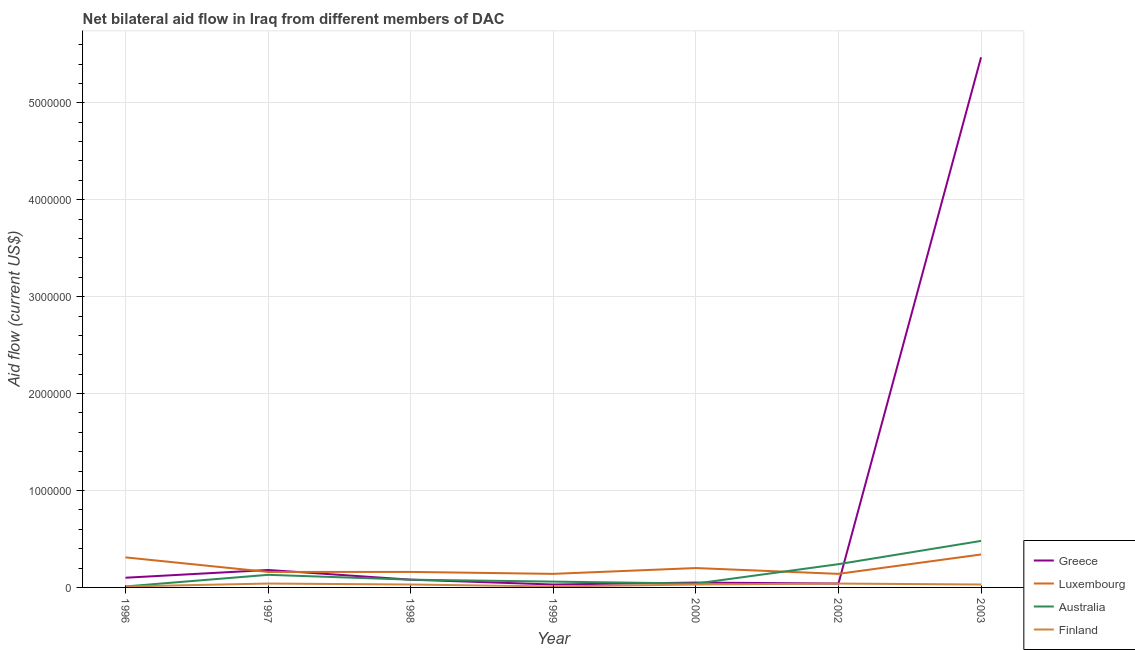What is the amount of aid given by australia in 2000?
Provide a short and direct response. 4.00e+04. Across all years, what is the maximum amount of aid given by luxembourg?
Give a very brief answer. 3.40e+05. Across all years, what is the minimum amount of aid given by greece?
Provide a succinct answer. 3.00e+04. In which year was the amount of aid given by australia minimum?
Your answer should be very brief. 1996. What is the total amount of aid given by luxembourg in the graph?
Make the answer very short. 1.45e+06. What is the difference between the amount of aid given by australia in 1998 and that in 1999?
Offer a very short reply. 2.00e+04. What is the difference between the amount of aid given by finland in 1997 and the amount of aid given by australia in 2003?
Make the answer very short. -4.40e+05. What is the average amount of aid given by australia per year?
Keep it short and to the point. 1.49e+05. In the year 2003, what is the difference between the amount of aid given by finland and amount of aid given by australia?
Ensure brevity in your answer.  -4.50e+05. In how many years, is the amount of aid given by australia greater than 4600000 US$?
Provide a succinct answer. 0. What is the ratio of the amount of aid given by luxembourg in 2000 to that in 2002?
Offer a terse response. 1.43. Is the difference between the amount of aid given by luxembourg in 1996 and 2003 greater than the difference between the amount of aid given by greece in 1996 and 2003?
Ensure brevity in your answer.  Yes. What is the difference between the highest and the second highest amount of aid given by greece?
Your answer should be compact. 5.29e+06. What is the difference between the highest and the lowest amount of aid given by australia?
Provide a short and direct response. 4.70e+05. In how many years, is the amount of aid given by luxembourg greater than the average amount of aid given by luxembourg taken over all years?
Provide a short and direct response. 2. Is the sum of the amount of aid given by finland in 1999 and 2002 greater than the maximum amount of aid given by luxembourg across all years?
Offer a terse response. No. Is it the case that in every year, the sum of the amount of aid given by greece and amount of aid given by luxembourg is greater than the amount of aid given by australia?
Provide a succinct answer. No. Does the amount of aid given by australia monotonically increase over the years?
Your answer should be very brief. No. Is the amount of aid given by greece strictly greater than the amount of aid given by luxembourg over the years?
Give a very brief answer. No. Is the amount of aid given by australia strictly less than the amount of aid given by luxembourg over the years?
Provide a succinct answer. No. How many lines are there?
Ensure brevity in your answer.  4. What is the difference between two consecutive major ticks on the Y-axis?
Keep it short and to the point. 1.00e+06. Does the graph contain any zero values?
Your answer should be very brief. No. Does the graph contain grids?
Make the answer very short. Yes. How many legend labels are there?
Ensure brevity in your answer.  4. What is the title of the graph?
Provide a short and direct response. Net bilateral aid flow in Iraq from different members of DAC. What is the label or title of the Y-axis?
Ensure brevity in your answer.  Aid flow (current US$). What is the Aid flow (current US$) of Luxembourg in 1996?
Provide a succinct answer. 3.10e+05. What is the Aid flow (current US$) in Australia in 1996?
Keep it short and to the point. 10000. What is the Aid flow (current US$) in Finland in 1996?
Make the answer very short. 10000. What is the Aid flow (current US$) of Australia in 1997?
Your response must be concise. 1.30e+05. What is the Aid flow (current US$) of Greece in 1998?
Your response must be concise. 8.00e+04. What is the Aid flow (current US$) of Greece in 1999?
Ensure brevity in your answer.  3.00e+04. What is the Aid flow (current US$) of Luxembourg in 1999?
Your answer should be very brief. 1.40e+05. What is the Aid flow (current US$) in Australia in 1999?
Your answer should be very brief. 6.00e+04. What is the Aid flow (current US$) in Greece in 2000?
Your response must be concise. 5.00e+04. What is the Aid flow (current US$) of Luxembourg in 2000?
Ensure brevity in your answer.  2.00e+05. What is the Aid flow (current US$) of Australia in 2000?
Give a very brief answer. 4.00e+04. What is the Aid flow (current US$) in Australia in 2002?
Your answer should be very brief. 2.40e+05. What is the Aid flow (current US$) of Finland in 2002?
Keep it short and to the point. 4.00e+04. What is the Aid flow (current US$) in Greece in 2003?
Make the answer very short. 5.47e+06. What is the Aid flow (current US$) in Australia in 2003?
Offer a terse response. 4.80e+05. What is the Aid flow (current US$) of Finland in 2003?
Give a very brief answer. 3.00e+04. Across all years, what is the maximum Aid flow (current US$) in Greece?
Offer a terse response. 5.47e+06. Across all years, what is the maximum Aid flow (current US$) in Luxembourg?
Offer a very short reply. 3.40e+05. Across all years, what is the maximum Aid flow (current US$) of Australia?
Your answer should be very brief. 4.80e+05. What is the total Aid flow (current US$) in Greece in the graph?
Your response must be concise. 5.95e+06. What is the total Aid flow (current US$) in Luxembourg in the graph?
Provide a short and direct response. 1.45e+06. What is the total Aid flow (current US$) in Australia in the graph?
Make the answer very short. 1.04e+06. What is the total Aid flow (current US$) of Finland in the graph?
Offer a very short reply. 1.90e+05. What is the difference between the Aid flow (current US$) in Greece in 1996 and that in 1997?
Give a very brief answer. -8.00e+04. What is the difference between the Aid flow (current US$) in Luxembourg in 1996 and that in 1997?
Your response must be concise. 1.50e+05. What is the difference between the Aid flow (current US$) of Australia in 1996 and that in 1997?
Provide a succinct answer. -1.20e+05. What is the difference between the Aid flow (current US$) in Finland in 1996 and that in 1997?
Your answer should be compact. -3.00e+04. What is the difference between the Aid flow (current US$) of Greece in 1996 and that in 1998?
Provide a short and direct response. 2.00e+04. What is the difference between the Aid flow (current US$) in Finland in 1996 and that in 1998?
Your answer should be compact. -2.00e+04. What is the difference between the Aid flow (current US$) in Finland in 1996 and that in 1999?
Make the answer very short. 0. What is the difference between the Aid flow (current US$) of Greece in 1996 and that in 2000?
Your answer should be very brief. 5.00e+04. What is the difference between the Aid flow (current US$) of Australia in 1996 and that in 2000?
Make the answer very short. -3.00e+04. What is the difference between the Aid flow (current US$) of Luxembourg in 1996 and that in 2002?
Your response must be concise. 1.70e+05. What is the difference between the Aid flow (current US$) of Greece in 1996 and that in 2003?
Offer a terse response. -5.37e+06. What is the difference between the Aid flow (current US$) of Luxembourg in 1996 and that in 2003?
Provide a succinct answer. -3.00e+04. What is the difference between the Aid flow (current US$) in Australia in 1996 and that in 2003?
Provide a short and direct response. -4.70e+05. What is the difference between the Aid flow (current US$) of Finland in 1996 and that in 2003?
Provide a short and direct response. -2.00e+04. What is the difference between the Aid flow (current US$) of Australia in 1997 and that in 1998?
Offer a terse response. 5.00e+04. What is the difference between the Aid flow (current US$) of Finland in 1997 and that in 1998?
Offer a very short reply. 10000. What is the difference between the Aid flow (current US$) of Luxembourg in 1997 and that in 1999?
Your answer should be compact. 2.00e+04. What is the difference between the Aid flow (current US$) in Australia in 1997 and that in 1999?
Provide a succinct answer. 7.00e+04. What is the difference between the Aid flow (current US$) in Luxembourg in 1997 and that in 2000?
Provide a succinct answer. -4.00e+04. What is the difference between the Aid flow (current US$) in Australia in 1997 and that in 2000?
Make the answer very short. 9.00e+04. What is the difference between the Aid flow (current US$) of Finland in 1997 and that in 2000?
Your answer should be compact. 10000. What is the difference between the Aid flow (current US$) of Greece in 1997 and that in 2002?
Offer a very short reply. 1.40e+05. What is the difference between the Aid flow (current US$) in Luxembourg in 1997 and that in 2002?
Make the answer very short. 2.00e+04. What is the difference between the Aid flow (current US$) of Finland in 1997 and that in 2002?
Your answer should be compact. 0. What is the difference between the Aid flow (current US$) of Greece in 1997 and that in 2003?
Keep it short and to the point. -5.29e+06. What is the difference between the Aid flow (current US$) in Luxembourg in 1997 and that in 2003?
Ensure brevity in your answer.  -1.80e+05. What is the difference between the Aid flow (current US$) of Australia in 1997 and that in 2003?
Give a very brief answer. -3.50e+05. What is the difference between the Aid flow (current US$) of Finland in 1997 and that in 2003?
Your response must be concise. 10000. What is the difference between the Aid flow (current US$) in Luxembourg in 1998 and that in 1999?
Provide a short and direct response. 2.00e+04. What is the difference between the Aid flow (current US$) of Australia in 1998 and that in 1999?
Your answer should be very brief. 2.00e+04. What is the difference between the Aid flow (current US$) of Finland in 1998 and that in 1999?
Offer a terse response. 2.00e+04. What is the difference between the Aid flow (current US$) in Luxembourg in 1998 and that in 2000?
Offer a terse response. -4.00e+04. What is the difference between the Aid flow (current US$) in Finland in 1998 and that in 2000?
Make the answer very short. 0. What is the difference between the Aid flow (current US$) of Greece in 1998 and that in 2002?
Offer a very short reply. 4.00e+04. What is the difference between the Aid flow (current US$) in Luxembourg in 1998 and that in 2002?
Your answer should be very brief. 2.00e+04. What is the difference between the Aid flow (current US$) in Australia in 1998 and that in 2002?
Your answer should be compact. -1.60e+05. What is the difference between the Aid flow (current US$) of Finland in 1998 and that in 2002?
Your answer should be very brief. -10000. What is the difference between the Aid flow (current US$) of Greece in 1998 and that in 2003?
Give a very brief answer. -5.39e+06. What is the difference between the Aid flow (current US$) in Luxembourg in 1998 and that in 2003?
Give a very brief answer. -1.80e+05. What is the difference between the Aid flow (current US$) in Australia in 1998 and that in 2003?
Ensure brevity in your answer.  -4.00e+05. What is the difference between the Aid flow (current US$) in Finland in 1998 and that in 2003?
Provide a succinct answer. 0. What is the difference between the Aid flow (current US$) of Greece in 1999 and that in 2000?
Ensure brevity in your answer.  -2.00e+04. What is the difference between the Aid flow (current US$) of Luxembourg in 1999 and that in 2000?
Keep it short and to the point. -6.00e+04. What is the difference between the Aid flow (current US$) in Australia in 1999 and that in 2000?
Your response must be concise. 2.00e+04. What is the difference between the Aid flow (current US$) in Finland in 1999 and that in 2000?
Your answer should be very brief. -2.00e+04. What is the difference between the Aid flow (current US$) of Greece in 1999 and that in 2002?
Keep it short and to the point. -10000. What is the difference between the Aid flow (current US$) of Luxembourg in 1999 and that in 2002?
Your answer should be compact. 0. What is the difference between the Aid flow (current US$) of Greece in 1999 and that in 2003?
Offer a very short reply. -5.44e+06. What is the difference between the Aid flow (current US$) of Australia in 1999 and that in 2003?
Your answer should be compact. -4.20e+05. What is the difference between the Aid flow (current US$) of Finland in 1999 and that in 2003?
Provide a succinct answer. -2.00e+04. What is the difference between the Aid flow (current US$) of Luxembourg in 2000 and that in 2002?
Your response must be concise. 6.00e+04. What is the difference between the Aid flow (current US$) in Greece in 2000 and that in 2003?
Provide a short and direct response. -5.42e+06. What is the difference between the Aid flow (current US$) in Luxembourg in 2000 and that in 2003?
Offer a terse response. -1.40e+05. What is the difference between the Aid flow (current US$) in Australia in 2000 and that in 2003?
Your response must be concise. -4.40e+05. What is the difference between the Aid flow (current US$) in Greece in 2002 and that in 2003?
Your response must be concise. -5.43e+06. What is the difference between the Aid flow (current US$) in Australia in 2002 and that in 2003?
Your answer should be compact. -2.40e+05. What is the difference between the Aid flow (current US$) in Greece in 1996 and the Aid flow (current US$) in Luxembourg in 1997?
Offer a terse response. -6.00e+04. What is the difference between the Aid flow (current US$) in Greece in 1996 and the Aid flow (current US$) in Finland in 1997?
Ensure brevity in your answer.  6.00e+04. What is the difference between the Aid flow (current US$) of Luxembourg in 1996 and the Aid flow (current US$) of Australia in 1997?
Provide a succinct answer. 1.80e+05. What is the difference between the Aid flow (current US$) in Luxembourg in 1996 and the Aid flow (current US$) in Finland in 1997?
Offer a terse response. 2.70e+05. What is the difference between the Aid flow (current US$) in Greece in 1996 and the Aid flow (current US$) in Luxembourg in 1998?
Provide a succinct answer. -6.00e+04. What is the difference between the Aid flow (current US$) in Greece in 1996 and the Aid flow (current US$) in Australia in 1998?
Your response must be concise. 2.00e+04. What is the difference between the Aid flow (current US$) in Greece in 1996 and the Aid flow (current US$) in Finland in 1998?
Keep it short and to the point. 7.00e+04. What is the difference between the Aid flow (current US$) of Luxembourg in 1996 and the Aid flow (current US$) of Australia in 1998?
Your answer should be compact. 2.30e+05. What is the difference between the Aid flow (current US$) of Luxembourg in 1996 and the Aid flow (current US$) of Finland in 1998?
Your answer should be compact. 2.80e+05. What is the difference between the Aid flow (current US$) of Greece in 1996 and the Aid flow (current US$) of Luxembourg in 1999?
Your answer should be very brief. -4.00e+04. What is the difference between the Aid flow (current US$) of Greece in 1996 and the Aid flow (current US$) of Finland in 1999?
Offer a terse response. 9.00e+04. What is the difference between the Aid flow (current US$) of Luxembourg in 1996 and the Aid flow (current US$) of Australia in 1999?
Ensure brevity in your answer.  2.50e+05. What is the difference between the Aid flow (current US$) of Luxembourg in 1996 and the Aid flow (current US$) of Finland in 1999?
Provide a short and direct response. 3.00e+05. What is the difference between the Aid flow (current US$) in Australia in 1996 and the Aid flow (current US$) in Finland in 1999?
Provide a succinct answer. 0. What is the difference between the Aid flow (current US$) in Greece in 1996 and the Aid flow (current US$) in Luxembourg in 2000?
Your answer should be compact. -1.00e+05. What is the difference between the Aid flow (current US$) in Greece in 1996 and the Aid flow (current US$) in Australia in 2000?
Offer a terse response. 6.00e+04. What is the difference between the Aid flow (current US$) in Greece in 1996 and the Aid flow (current US$) in Finland in 2000?
Provide a short and direct response. 7.00e+04. What is the difference between the Aid flow (current US$) in Luxembourg in 1996 and the Aid flow (current US$) in Australia in 2000?
Keep it short and to the point. 2.70e+05. What is the difference between the Aid flow (current US$) in Australia in 1996 and the Aid flow (current US$) in Finland in 2000?
Keep it short and to the point. -2.00e+04. What is the difference between the Aid flow (current US$) in Greece in 1996 and the Aid flow (current US$) in Finland in 2002?
Your answer should be very brief. 6.00e+04. What is the difference between the Aid flow (current US$) in Australia in 1996 and the Aid flow (current US$) in Finland in 2002?
Your answer should be very brief. -3.00e+04. What is the difference between the Aid flow (current US$) in Greece in 1996 and the Aid flow (current US$) in Luxembourg in 2003?
Keep it short and to the point. -2.40e+05. What is the difference between the Aid flow (current US$) of Greece in 1996 and the Aid flow (current US$) of Australia in 2003?
Your answer should be compact. -3.80e+05. What is the difference between the Aid flow (current US$) of Greece in 1996 and the Aid flow (current US$) of Finland in 2003?
Give a very brief answer. 7.00e+04. What is the difference between the Aid flow (current US$) in Luxembourg in 1996 and the Aid flow (current US$) in Finland in 2003?
Make the answer very short. 2.80e+05. What is the difference between the Aid flow (current US$) in Greece in 1997 and the Aid flow (current US$) in Luxembourg in 1998?
Keep it short and to the point. 2.00e+04. What is the difference between the Aid flow (current US$) of Greece in 1997 and the Aid flow (current US$) of Australia in 1998?
Your response must be concise. 1.00e+05. What is the difference between the Aid flow (current US$) in Luxembourg in 1997 and the Aid flow (current US$) in Australia in 1998?
Provide a succinct answer. 8.00e+04. What is the difference between the Aid flow (current US$) of Luxembourg in 1997 and the Aid flow (current US$) of Finland in 1998?
Your answer should be very brief. 1.30e+05. What is the difference between the Aid flow (current US$) in Greece in 1997 and the Aid flow (current US$) in Luxembourg in 1999?
Keep it short and to the point. 4.00e+04. What is the difference between the Aid flow (current US$) in Greece in 1997 and the Aid flow (current US$) in Finland in 1999?
Keep it short and to the point. 1.70e+05. What is the difference between the Aid flow (current US$) in Luxembourg in 1997 and the Aid flow (current US$) in Australia in 1999?
Your answer should be very brief. 1.00e+05. What is the difference between the Aid flow (current US$) in Luxembourg in 1997 and the Aid flow (current US$) in Finland in 1999?
Make the answer very short. 1.50e+05. What is the difference between the Aid flow (current US$) in Australia in 1997 and the Aid flow (current US$) in Finland in 1999?
Ensure brevity in your answer.  1.20e+05. What is the difference between the Aid flow (current US$) of Greece in 1997 and the Aid flow (current US$) of Australia in 2000?
Give a very brief answer. 1.40e+05. What is the difference between the Aid flow (current US$) in Greece in 1997 and the Aid flow (current US$) in Finland in 2000?
Your response must be concise. 1.50e+05. What is the difference between the Aid flow (current US$) of Luxembourg in 1997 and the Aid flow (current US$) of Australia in 2000?
Provide a succinct answer. 1.20e+05. What is the difference between the Aid flow (current US$) in Luxembourg in 1997 and the Aid flow (current US$) in Australia in 2002?
Provide a short and direct response. -8.00e+04. What is the difference between the Aid flow (current US$) of Luxembourg in 1997 and the Aid flow (current US$) of Finland in 2002?
Provide a short and direct response. 1.20e+05. What is the difference between the Aid flow (current US$) of Australia in 1997 and the Aid flow (current US$) of Finland in 2002?
Provide a succinct answer. 9.00e+04. What is the difference between the Aid flow (current US$) of Greece in 1997 and the Aid flow (current US$) of Australia in 2003?
Offer a terse response. -3.00e+05. What is the difference between the Aid flow (current US$) of Luxembourg in 1997 and the Aid flow (current US$) of Australia in 2003?
Offer a very short reply. -3.20e+05. What is the difference between the Aid flow (current US$) of Greece in 1998 and the Aid flow (current US$) of Australia in 1999?
Give a very brief answer. 2.00e+04. What is the difference between the Aid flow (current US$) in Australia in 1998 and the Aid flow (current US$) in Finland in 1999?
Keep it short and to the point. 7.00e+04. What is the difference between the Aid flow (current US$) of Greece in 1998 and the Aid flow (current US$) of Luxembourg in 2000?
Your answer should be very brief. -1.20e+05. What is the difference between the Aid flow (current US$) of Greece in 1998 and the Aid flow (current US$) of Finland in 2000?
Ensure brevity in your answer.  5.00e+04. What is the difference between the Aid flow (current US$) of Luxembourg in 1998 and the Aid flow (current US$) of Australia in 2000?
Make the answer very short. 1.20e+05. What is the difference between the Aid flow (current US$) of Greece in 1998 and the Aid flow (current US$) of Luxembourg in 2002?
Give a very brief answer. -6.00e+04. What is the difference between the Aid flow (current US$) of Luxembourg in 1998 and the Aid flow (current US$) of Australia in 2002?
Make the answer very short. -8.00e+04. What is the difference between the Aid flow (current US$) of Greece in 1998 and the Aid flow (current US$) of Luxembourg in 2003?
Ensure brevity in your answer.  -2.60e+05. What is the difference between the Aid flow (current US$) of Greece in 1998 and the Aid flow (current US$) of Australia in 2003?
Your response must be concise. -4.00e+05. What is the difference between the Aid flow (current US$) of Luxembourg in 1998 and the Aid flow (current US$) of Australia in 2003?
Offer a very short reply. -3.20e+05. What is the difference between the Aid flow (current US$) of Luxembourg in 1998 and the Aid flow (current US$) of Finland in 2003?
Offer a terse response. 1.30e+05. What is the difference between the Aid flow (current US$) of Australia in 1998 and the Aid flow (current US$) of Finland in 2003?
Your answer should be compact. 5.00e+04. What is the difference between the Aid flow (current US$) in Greece in 1999 and the Aid flow (current US$) in Luxembourg in 2000?
Your answer should be compact. -1.70e+05. What is the difference between the Aid flow (current US$) in Greece in 1999 and the Aid flow (current US$) in Australia in 2000?
Provide a short and direct response. -10000. What is the difference between the Aid flow (current US$) of Luxembourg in 1999 and the Aid flow (current US$) of Finland in 2000?
Your answer should be very brief. 1.10e+05. What is the difference between the Aid flow (current US$) of Australia in 1999 and the Aid flow (current US$) of Finland in 2002?
Offer a very short reply. 2.00e+04. What is the difference between the Aid flow (current US$) of Greece in 1999 and the Aid flow (current US$) of Luxembourg in 2003?
Provide a succinct answer. -3.10e+05. What is the difference between the Aid flow (current US$) of Greece in 1999 and the Aid flow (current US$) of Australia in 2003?
Provide a short and direct response. -4.50e+05. What is the difference between the Aid flow (current US$) in Luxembourg in 1999 and the Aid flow (current US$) in Australia in 2003?
Provide a succinct answer. -3.40e+05. What is the difference between the Aid flow (current US$) in Greece in 2000 and the Aid flow (current US$) in Luxembourg in 2002?
Ensure brevity in your answer.  -9.00e+04. What is the difference between the Aid flow (current US$) of Luxembourg in 2000 and the Aid flow (current US$) of Finland in 2002?
Your answer should be very brief. 1.60e+05. What is the difference between the Aid flow (current US$) in Australia in 2000 and the Aid flow (current US$) in Finland in 2002?
Make the answer very short. 0. What is the difference between the Aid flow (current US$) in Greece in 2000 and the Aid flow (current US$) in Luxembourg in 2003?
Your response must be concise. -2.90e+05. What is the difference between the Aid flow (current US$) of Greece in 2000 and the Aid flow (current US$) of Australia in 2003?
Keep it short and to the point. -4.30e+05. What is the difference between the Aid flow (current US$) of Greece in 2000 and the Aid flow (current US$) of Finland in 2003?
Give a very brief answer. 2.00e+04. What is the difference between the Aid flow (current US$) in Luxembourg in 2000 and the Aid flow (current US$) in Australia in 2003?
Your answer should be compact. -2.80e+05. What is the difference between the Aid flow (current US$) of Luxembourg in 2000 and the Aid flow (current US$) of Finland in 2003?
Ensure brevity in your answer.  1.70e+05. What is the difference between the Aid flow (current US$) in Greece in 2002 and the Aid flow (current US$) in Luxembourg in 2003?
Your response must be concise. -3.00e+05. What is the difference between the Aid flow (current US$) in Greece in 2002 and the Aid flow (current US$) in Australia in 2003?
Provide a short and direct response. -4.40e+05. What is the difference between the Aid flow (current US$) of Greece in 2002 and the Aid flow (current US$) of Finland in 2003?
Your answer should be very brief. 10000. What is the difference between the Aid flow (current US$) in Luxembourg in 2002 and the Aid flow (current US$) in Australia in 2003?
Your answer should be compact. -3.40e+05. What is the average Aid flow (current US$) of Greece per year?
Your answer should be compact. 8.50e+05. What is the average Aid flow (current US$) in Luxembourg per year?
Offer a terse response. 2.07e+05. What is the average Aid flow (current US$) in Australia per year?
Ensure brevity in your answer.  1.49e+05. What is the average Aid flow (current US$) of Finland per year?
Your answer should be compact. 2.71e+04. In the year 1996, what is the difference between the Aid flow (current US$) of Greece and Aid flow (current US$) of Luxembourg?
Your answer should be compact. -2.10e+05. In the year 1996, what is the difference between the Aid flow (current US$) of Greece and Aid flow (current US$) of Australia?
Provide a short and direct response. 9.00e+04. In the year 1996, what is the difference between the Aid flow (current US$) in Luxembourg and Aid flow (current US$) in Finland?
Provide a short and direct response. 3.00e+05. In the year 1996, what is the difference between the Aid flow (current US$) in Australia and Aid flow (current US$) in Finland?
Your response must be concise. 0. In the year 1997, what is the difference between the Aid flow (current US$) of Greece and Aid flow (current US$) of Luxembourg?
Provide a short and direct response. 2.00e+04. In the year 1997, what is the difference between the Aid flow (current US$) of Greece and Aid flow (current US$) of Finland?
Provide a succinct answer. 1.40e+05. In the year 1997, what is the difference between the Aid flow (current US$) of Luxembourg and Aid flow (current US$) of Australia?
Give a very brief answer. 3.00e+04. In the year 1997, what is the difference between the Aid flow (current US$) in Australia and Aid flow (current US$) in Finland?
Give a very brief answer. 9.00e+04. In the year 1998, what is the difference between the Aid flow (current US$) in Greece and Aid flow (current US$) in Luxembourg?
Provide a short and direct response. -8.00e+04. In the year 1998, what is the difference between the Aid flow (current US$) in Greece and Aid flow (current US$) in Finland?
Your response must be concise. 5.00e+04. In the year 1998, what is the difference between the Aid flow (current US$) in Luxembourg and Aid flow (current US$) in Australia?
Offer a terse response. 8.00e+04. In the year 1999, what is the difference between the Aid flow (current US$) in Luxembourg and Aid flow (current US$) in Finland?
Your response must be concise. 1.30e+05. In the year 2000, what is the difference between the Aid flow (current US$) of Greece and Aid flow (current US$) of Luxembourg?
Ensure brevity in your answer.  -1.50e+05. In the year 2000, what is the difference between the Aid flow (current US$) of Greece and Aid flow (current US$) of Finland?
Your response must be concise. 2.00e+04. In the year 2000, what is the difference between the Aid flow (current US$) in Luxembourg and Aid flow (current US$) in Finland?
Make the answer very short. 1.70e+05. In the year 2002, what is the difference between the Aid flow (current US$) in Greece and Aid flow (current US$) in Luxembourg?
Ensure brevity in your answer.  -1.00e+05. In the year 2002, what is the difference between the Aid flow (current US$) of Greece and Aid flow (current US$) of Australia?
Provide a succinct answer. -2.00e+05. In the year 2002, what is the difference between the Aid flow (current US$) in Greece and Aid flow (current US$) in Finland?
Your answer should be very brief. 0. In the year 2002, what is the difference between the Aid flow (current US$) in Luxembourg and Aid flow (current US$) in Australia?
Provide a succinct answer. -1.00e+05. In the year 2002, what is the difference between the Aid flow (current US$) of Luxembourg and Aid flow (current US$) of Finland?
Your answer should be very brief. 1.00e+05. In the year 2003, what is the difference between the Aid flow (current US$) of Greece and Aid flow (current US$) of Luxembourg?
Offer a very short reply. 5.13e+06. In the year 2003, what is the difference between the Aid flow (current US$) in Greece and Aid flow (current US$) in Australia?
Provide a succinct answer. 4.99e+06. In the year 2003, what is the difference between the Aid flow (current US$) of Greece and Aid flow (current US$) of Finland?
Your answer should be compact. 5.44e+06. In the year 2003, what is the difference between the Aid flow (current US$) of Luxembourg and Aid flow (current US$) of Finland?
Keep it short and to the point. 3.10e+05. What is the ratio of the Aid flow (current US$) of Greece in 1996 to that in 1997?
Ensure brevity in your answer.  0.56. What is the ratio of the Aid flow (current US$) in Luxembourg in 1996 to that in 1997?
Your response must be concise. 1.94. What is the ratio of the Aid flow (current US$) of Australia in 1996 to that in 1997?
Your answer should be very brief. 0.08. What is the ratio of the Aid flow (current US$) in Finland in 1996 to that in 1997?
Your answer should be very brief. 0.25. What is the ratio of the Aid flow (current US$) of Greece in 1996 to that in 1998?
Your answer should be very brief. 1.25. What is the ratio of the Aid flow (current US$) of Luxembourg in 1996 to that in 1998?
Your answer should be very brief. 1.94. What is the ratio of the Aid flow (current US$) of Australia in 1996 to that in 1998?
Your response must be concise. 0.12. What is the ratio of the Aid flow (current US$) of Finland in 1996 to that in 1998?
Your answer should be very brief. 0.33. What is the ratio of the Aid flow (current US$) in Greece in 1996 to that in 1999?
Make the answer very short. 3.33. What is the ratio of the Aid flow (current US$) in Luxembourg in 1996 to that in 1999?
Provide a succinct answer. 2.21. What is the ratio of the Aid flow (current US$) of Finland in 1996 to that in 1999?
Your response must be concise. 1. What is the ratio of the Aid flow (current US$) in Greece in 1996 to that in 2000?
Give a very brief answer. 2. What is the ratio of the Aid flow (current US$) in Luxembourg in 1996 to that in 2000?
Make the answer very short. 1.55. What is the ratio of the Aid flow (current US$) of Finland in 1996 to that in 2000?
Your answer should be very brief. 0.33. What is the ratio of the Aid flow (current US$) in Greece in 1996 to that in 2002?
Your answer should be compact. 2.5. What is the ratio of the Aid flow (current US$) in Luxembourg in 1996 to that in 2002?
Your response must be concise. 2.21. What is the ratio of the Aid flow (current US$) in Australia in 1996 to that in 2002?
Your response must be concise. 0.04. What is the ratio of the Aid flow (current US$) in Greece in 1996 to that in 2003?
Make the answer very short. 0.02. What is the ratio of the Aid flow (current US$) in Luxembourg in 1996 to that in 2003?
Offer a very short reply. 0.91. What is the ratio of the Aid flow (current US$) in Australia in 1996 to that in 2003?
Make the answer very short. 0.02. What is the ratio of the Aid flow (current US$) of Finland in 1996 to that in 2003?
Give a very brief answer. 0.33. What is the ratio of the Aid flow (current US$) in Greece in 1997 to that in 1998?
Your answer should be very brief. 2.25. What is the ratio of the Aid flow (current US$) of Australia in 1997 to that in 1998?
Your answer should be very brief. 1.62. What is the ratio of the Aid flow (current US$) of Luxembourg in 1997 to that in 1999?
Make the answer very short. 1.14. What is the ratio of the Aid flow (current US$) of Australia in 1997 to that in 1999?
Make the answer very short. 2.17. What is the ratio of the Aid flow (current US$) in Luxembourg in 1997 to that in 2000?
Keep it short and to the point. 0.8. What is the ratio of the Aid flow (current US$) of Greece in 1997 to that in 2002?
Your answer should be compact. 4.5. What is the ratio of the Aid flow (current US$) in Luxembourg in 1997 to that in 2002?
Keep it short and to the point. 1.14. What is the ratio of the Aid flow (current US$) of Australia in 1997 to that in 2002?
Offer a terse response. 0.54. What is the ratio of the Aid flow (current US$) in Greece in 1997 to that in 2003?
Ensure brevity in your answer.  0.03. What is the ratio of the Aid flow (current US$) of Luxembourg in 1997 to that in 2003?
Provide a succinct answer. 0.47. What is the ratio of the Aid flow (current US$) of Australia in 1997 to that in 2003?
Your answer should be very brief. 0.27. What is the ratio of the Aid flow (current US$) of Greece in 1998 to that in 1999?
Offer a very short reply. 2.67. What is the ratio of the Aid flow (current US$) of Australia in 1998 to that in 1999?
Your answer should be very brief. 1.33. What is the ratio of the Aid flow (current US$) of Finland in 1998 to that in 1999?
Provide a short and direct response. 3. What is the ratio of the Aid flow (current US$) in Finland in 1998 to that in 2000?
Provide a short and direct response. 1. What is the ratio of the Aid flow (current US$) of Greece in 1998 to that in 2002?
Ensure brevity in your answer.  2. What is the ratio of the Aid flow (current US$) in Australia in 1998 to that in 2002?
Keep it short and to the point. 0.33. What is the ratio of the Aid flow (current US$) of Greece in 1998 to that in 2003?
Your answer should be very brief. 0.01. What is the ratio of the Aid flow (current US$) in Luxembourg in 1998 to that in 2003?
Your answer should be very brief. 0.47. What is the ratio of the Aid flow (current US$) of Australia in 1998 to that in 2003?
Offer a terse response. 0.17. What is the ratio of the Aid flow (current US$) in Greece in 1999 to that in 2000?
Give a very brief answer. 0.6. What is the ratio of the Aid flow (current US$) in Luxembourg in 1999 to that in 2000?
Your answer should be compact. 0.7. What is the ratio of the Aid flow (current US$) in Finland in 1999 to that in 2000?
Provide a succinct answer. 0.33. What is the ratio of the Aid flow (current US$) of Australia in 1999 to that in 2002?
Your answer should be very brief. 0.25. What is the ratio of the Aid flow (current US$) of Greece in 1999 to that in 2003?
Your response must be concise. 0.01. What is the ratio of the Aid flow (current US$) of Luxembourg in 1999 to that in 2003?
Make the answer very short. 0.41. What is the ratio of the Aid flow (current US$) in Australia in 1999 to that in 2003?
Offer a very short reply. 0.12. What is the ratio of the Aid flow (current US$) of Luxembourg in 2000 to that in 2002?
Ensure brevity in your answer.  1.43. What is the ratio of the Aid flow (current US$) of Australia in 2000 to that in 2002?
Offer a very short reply. 0.17. What is the ratio of the Aid flow (current US$) of Finland in 2000 to that in 2002?
Your answer should be very brief. 0.75. What is the ratio of the Aid flow (current US$) in Greece in 2000 to that in 2003?
Give a very brief answer. 0.01. What is the ratio of the Aid flow (current US$) in Luxembourg in 2000 to that in 2003?
Offer a terse response. 0.59. What is the ratio of the Aid flow (current US$) of Australia in 2000 to that in 2003?
Make the answer very short. 0.08. What is the ratio of the Aid flow (current US$) of Greece in 2002 to that in 2003?
Keep it short and to the point. 0.01. What is the ratio of the Aid flow (current US$) of Luxembourg in 2002 to that in 2003?
Your answer should be very brief. 0.41. What is the ratio of the Aid flow (current US$) in Finland in 2002 to that in 2003?
Offer a terse response. 1.33. What is the difference between the highest and the second highest Aid flow (current US$) of Greece?
Your answer should be very brief. 5.29e+06. What is the difference between the highest and the lowest Aid flow (current US$) of Greece?
Make the answer very short. 5.44e+06. What is the difference between the highest and the lowest Aid flow (current US$) in Luxembourg?
Offer a very short reply. 2.00e+05. 